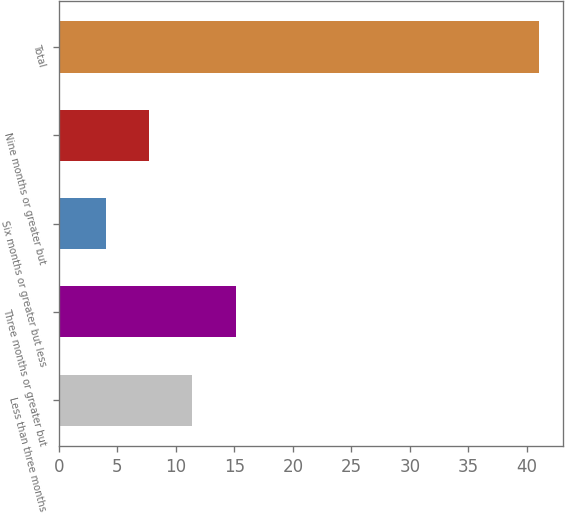Convert chart. <chart><loc_0><loc_0><loc_500><loc_500><bar_chart><fcel>Less than three months<fcel>Three months or greater but<fcel>Six months or greater but less<fcel>Nine months or greater but<fcel>Total<nl><fcel>11.4<fcel>15.1<fcel>4<fcel>7.7<fcel>41<nl></chart> 